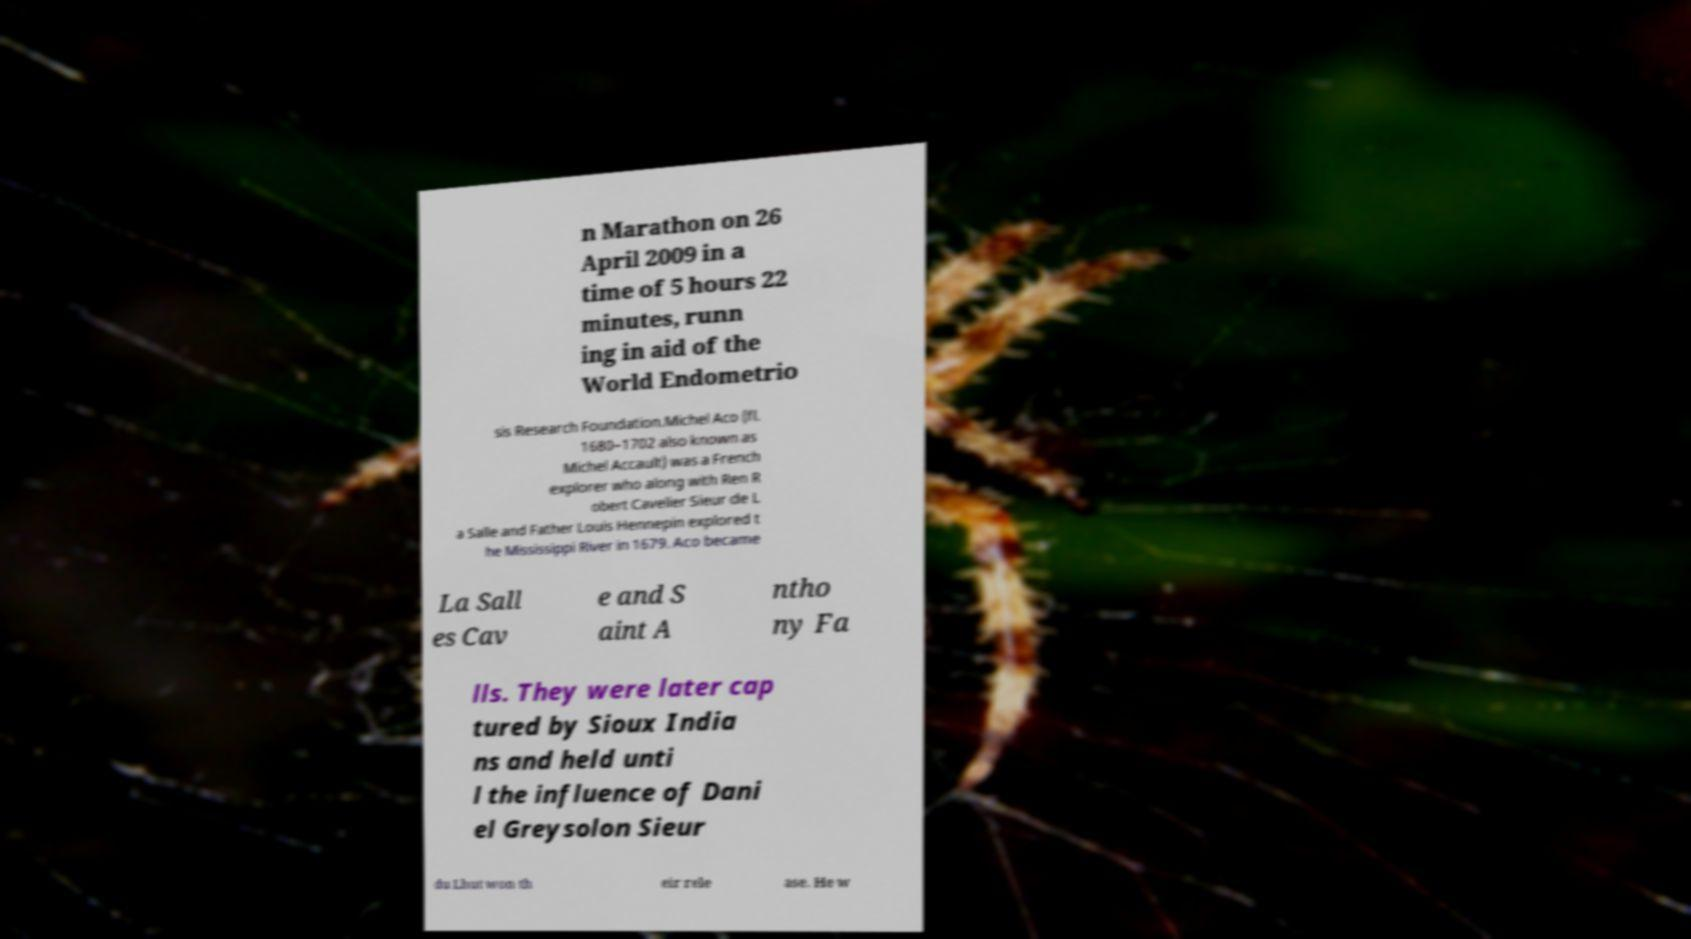Please read and relay the text visible in this image. What does it say? n Marathon on 26 April 2009 in a time of 5 hours 22 minutes, runn ing in aid of the World Endometrio sis Research Foundation.Michel Aco (fl. 1680–1702 also known as Michel Accault) was a French explorer who along with Ren R obert Cavelier Sieur de L a Salle and Father Louis Hennepin explored t he Mississippi River in 1679. Aco became La Sall es Cav e and S aint A ntho ny Fa lls. They were later cap tured by Sioux India ns and held unti l the influence of Dani el Greysolon Sieur du Lhut won th eir rele ase. He w 